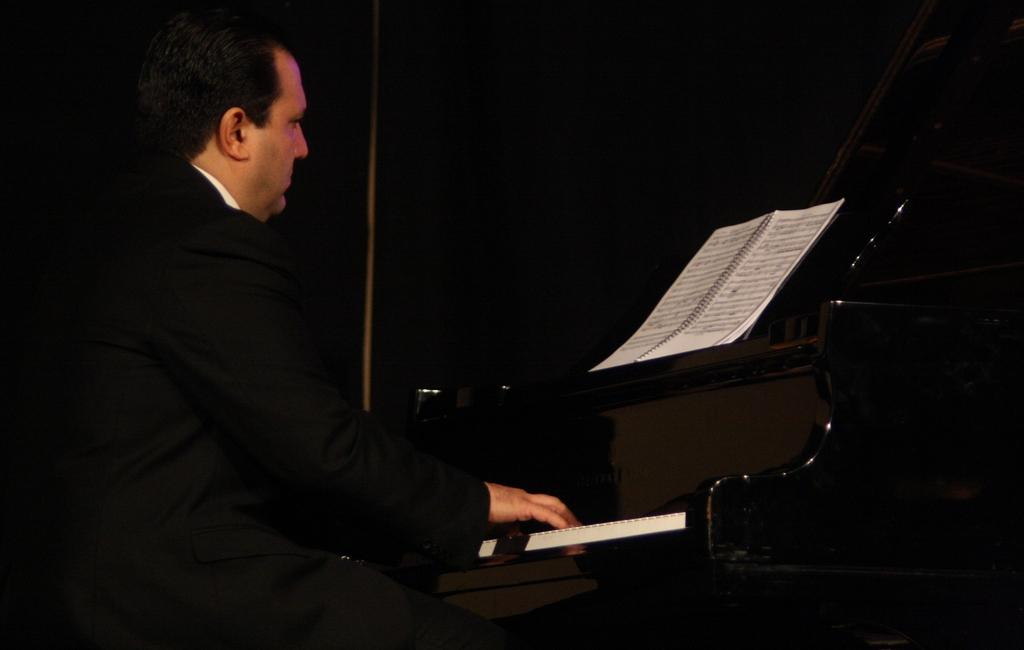Who is present in the image? There is a man present in the image. What object can be seen in the image related to music? There is a piano in the image in the image. What other object can be seen in the image related to reading or learning? There is a book in the image. What type of machine is used to measure the man's height in the image? There is no machine present in the image to measure the man's height. 